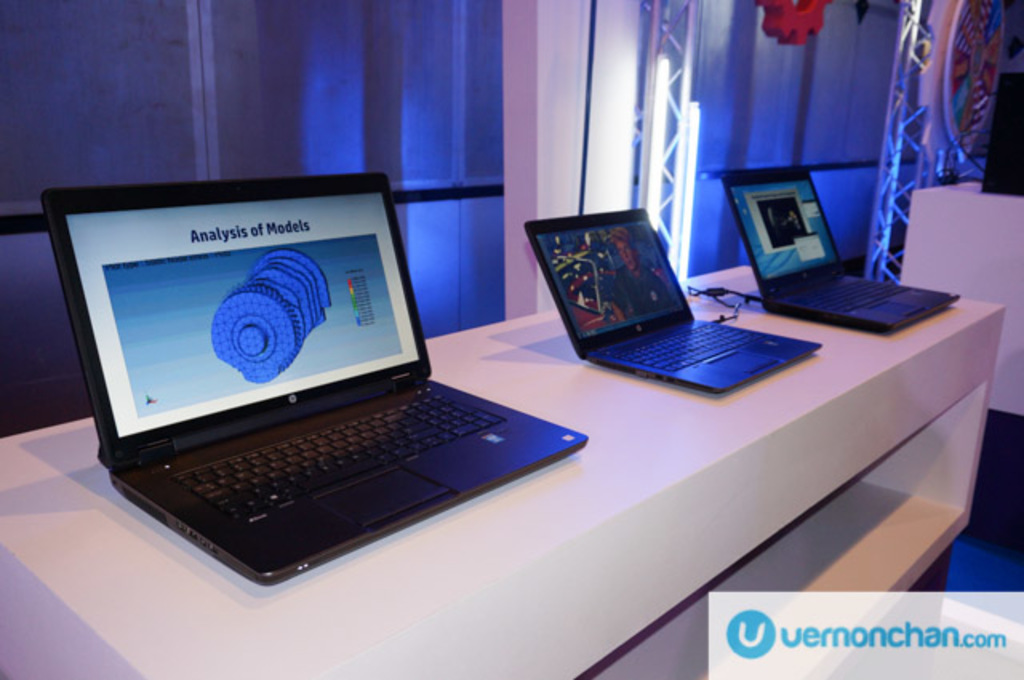Can you describe the setting in which these laptops are placed? The laptops are placed in an exhibition environment, likely at a tech conference or demo area, where they are used to showcase specific software capabilities to attendees. What does the lighting and background suggest about the ambience of this setting? The blue lighting and modern, minimalistic background suggest a professional and tech-focused ambience, typical of technology expos and high-tech industry events. 